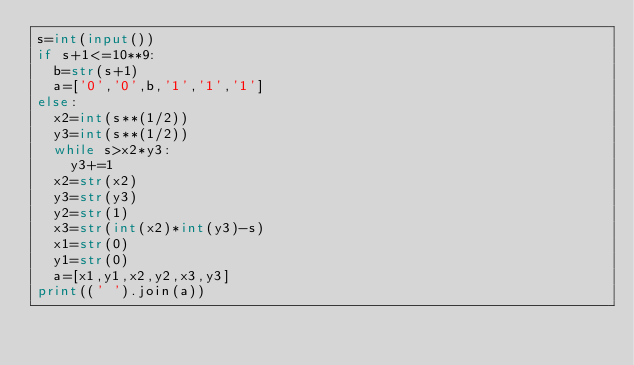<code> <loc_0><loc_0><loc_500><loc_500><_Python_>s=int(input())
if s+1<=10**9:
  b=str(s+1)
  a=['0','0',b,'1','1','1']
else:
  x2=int(s**(1/2))
  y3=int(s**(1/2))
  while s>x2*y3:
    y3+=1
  x2=str(x2)
  y3=str(y3)
  y2=str(1)
  x3=str(int(x2)*int(y3)-s)
  x1=str(0)
  y1=str(0)
  a=[x1,y1,x2,y2,x3,y3]
print((' ').join(a))
</code> 